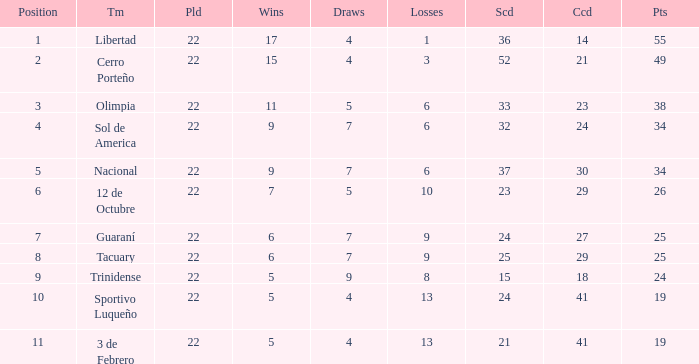What was the number of losses when the scored value was 25? 9.0. 